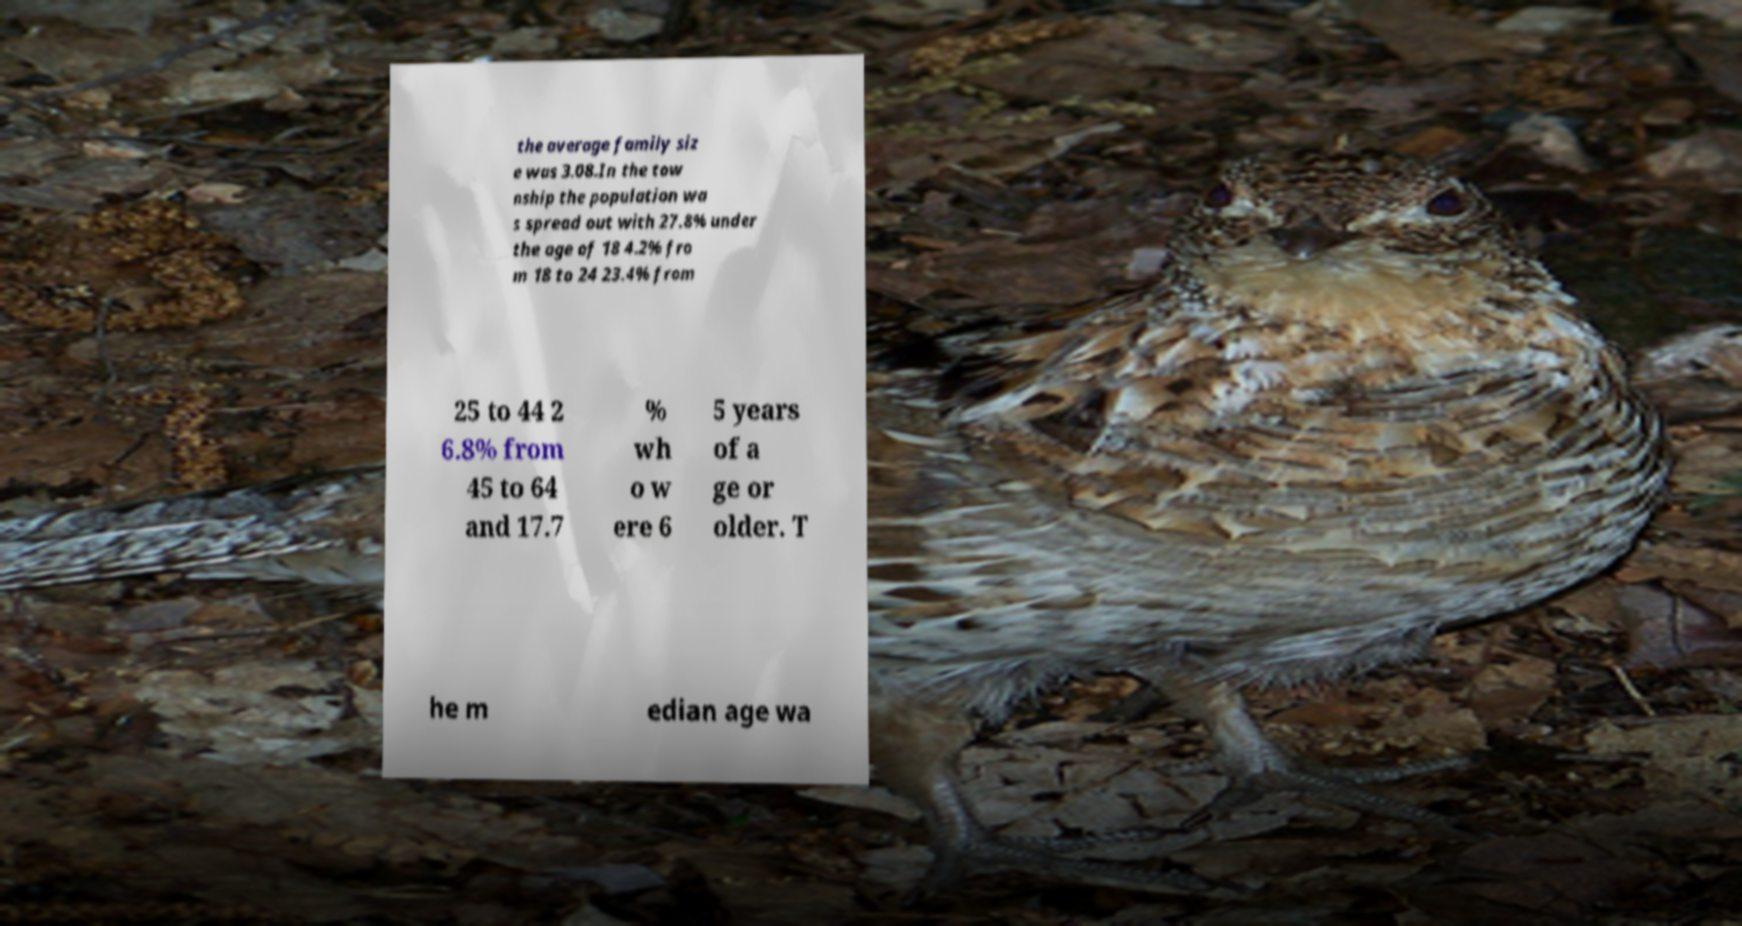Could you extract and type out the text from this image? the average family siz e was 3.08.In the tow nship the population wa s spread out with 27.8% under the age of 18 4.2% fro m 18 to 24 23.4% from 25 to 44 2 6.8% from 45 to 64 and 17.7 % wh o w ere 6 5 years of a ge or older. T he m edian age wa 